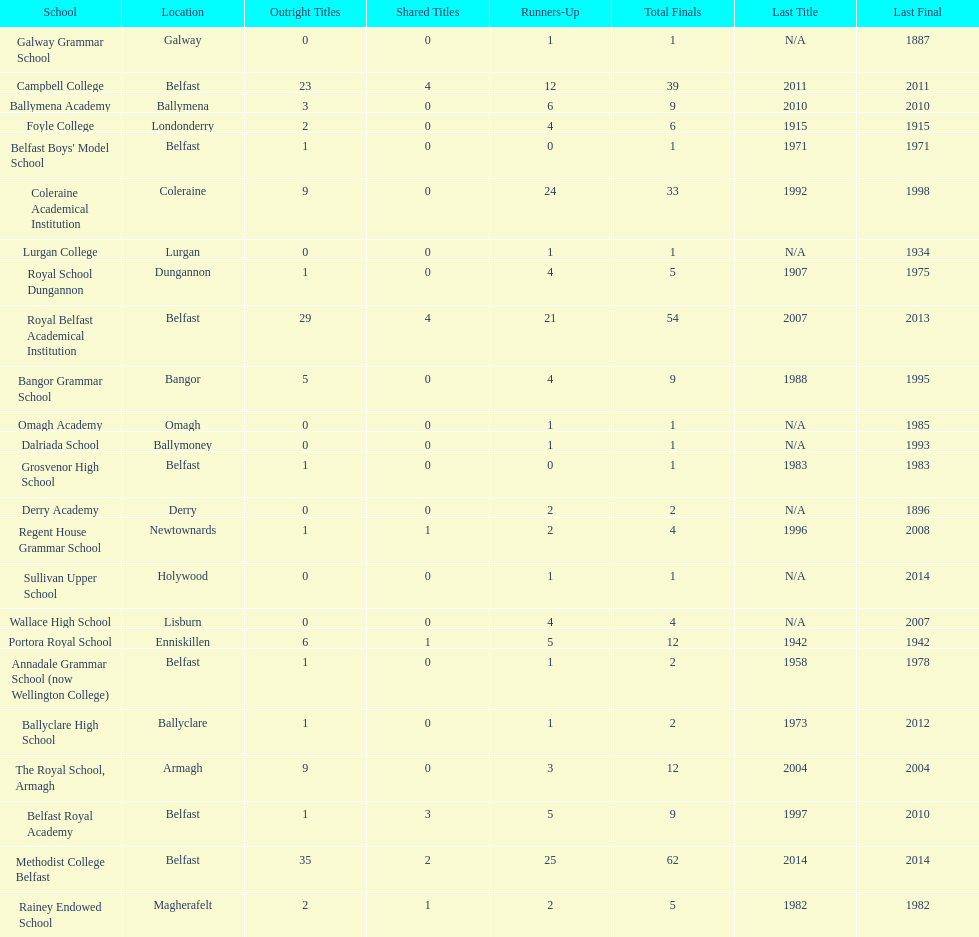How many schools are there? Methodist College Belfast, Royal Belfast Academical Institution, Campbell College, Coleraine Academical Institution, The Royal School, Armagh, Portora Royal School, Bangor Grammar School, Ballymena Academy, Rainey Endowed School, Foyle College, Belfast Royal Academy, Regent House Grammar School, Royal School Dungannon, Annadale Grammar School (now Wellington College), Ballyclare High School, Belfast Boys' Model School, Grosvenor High School, Wallace High School, Derry Academy, Dalriada School, Galway Grammar School, Lurgan College, Omagh Academy, Sullivan Upper School. How many outright titles does the coleraine academical institution have? 9. What other school has the same number of outright titles? The Royal School, Armagh. 